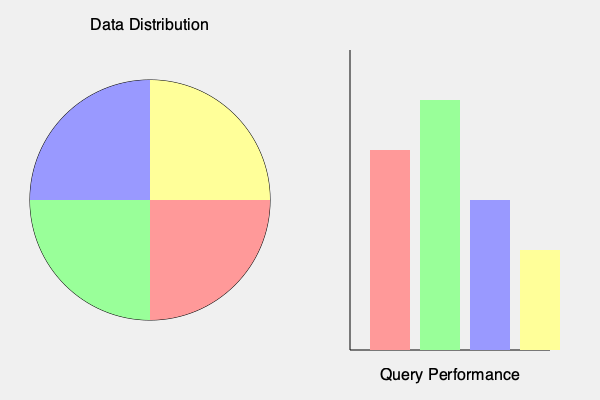Based on the pie chart showing data distribution and the bar graph indicating query performance for different partitioning strategies, which partitioning approach would you recommend for optimizing the e-commerce company's SQL database performance? To determine the best partitioning strategy, we need to analyze both the data distribution and query performance:

1. Data Distribution (Pie Chart):
   - Red segment (top-right): ~25%
   - Green segment (bottom-right): ~25%
   - Blue segment (bottom-left): ~25%
   - Yellow segment (top-left): ~25%

   The data appears to be evenly distributed across four segments.

2. Query Performance (Bar Graph):
   - Red bar: Moderate performance
   - Green bar: Highest performance
   - Blue bar: Lower performance
   - Yellow bar: Lowest performance

3. Analysis:
   a) The even data distribution suggests that any partitioning strategy could potentially work well.
   b) However, the query performance varies significantly among the different strategies.
   c) The green bar shows the highest performance, indicating that the corresponding partitioning strategy (second from left) is the most efficient for query execution.

4. Recommendation:
   Given that the data is evenly distributed and the green bar shows the best query performance, we should choose the partitioning strategy represented by the green segments/bars.

5. Implementation:
   In an e-commerce context, this could represent partitioning by:
   - Customer segments
   - Product categories
   - Geographical regions
   - Time-based partitions (e.g., quarterly data)

   The specific choice would depend on the most common query patterns in the e-commerce platform.
Answer: Green partitioning strategy (second from left) 